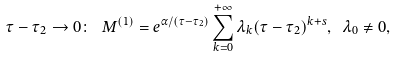Convert formula to latex. <formula><loc_0><loc_0><loc_500><loc_500>\tau - \tau _ { 2 } \to 0 \colon \ M ^ { ( 1 ) } = e ^ { \alpha / ( \tau - \tau _ { 2 } ) } \sum _ { k = 0 } ^ { + \infty } \lambda _ { k } ( \tau - \tau _ { 2 } ) ^ { k + s } , \ \lambda _ { 0 } \not = 0 ,</formula> 